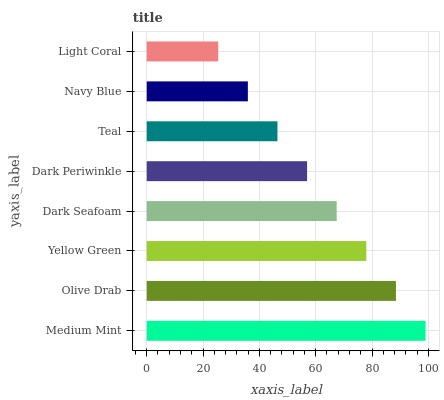Is Light Coral the minimum?
Answer yes or no. Yes. Is Medium Mint the maximum?
Answer yes or no. Yes. Is Olive Drab the minimum?
Answer yes or no. No. Is Olive Drab the maximum?
Answer yes or no. No. Is Medium Mint greater than Olive Drab?
Answer yes or no. Yes. Is Olive Drab less than Medium Mint?
Answer yes or no. Yes. Is Olive Drab greater than Medium Mint?
Answer yes or no. No. Is Medium Mint less than Olive Drab?
Answer yes or no. No. Is Dark Seafoam the high median?
Answer yes or no. Yes. Is Dark Periwinkle the low median?
Answer yes or no. Yes. Is Olive Drab the high median?
Answer yes or no. No. Is Navy Blue the low median?
Answer yes or no. No. 